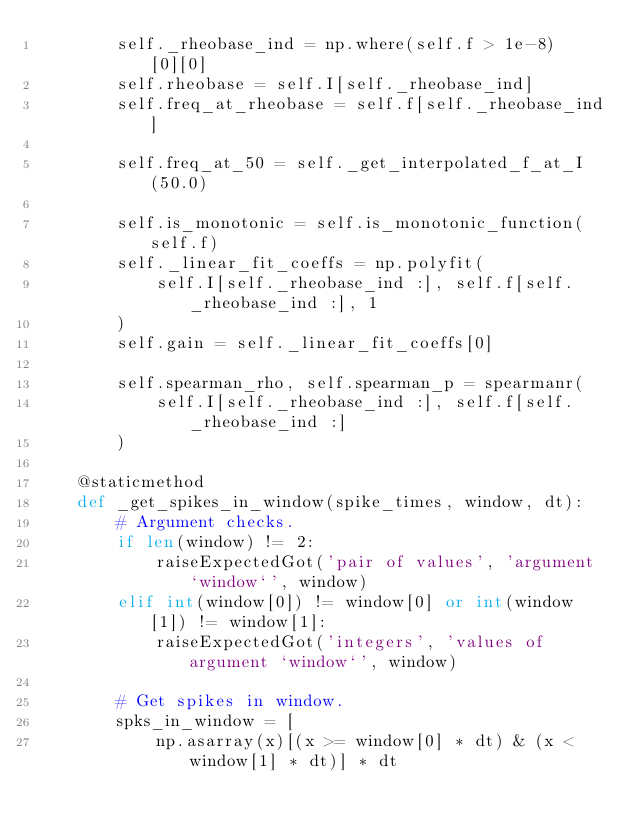<code> <loc_0><loc_0><loc_500><loc_500><_Python_>        self._rheobase_ind = np.where(self.f > 1e-8)[0][0]
        self.rheobase = self.I[self._rheobase_ind]
        self.freq_at_rheobase = self.f[self._rheobase_ind]

        self.freq_at_50 = self._get_interpolated_f_at_I(50.0)

        self.is_monotonic = self.is_monotonic_function(self.f)
        self._linear_fit_coeffs = np.polyfit(
            self.I[self._rheobase_ind :], self.f[self._rheobase_ind :], 1
        )
        self.gain = self._linear_fit_coeffs[0]

        self.spearman_rho, self.spearman_p = spearmanr(
            self.I[self._rheobase_ind :], self.f[self._rheobase_ind :]
        )

    @staticmethod
    def _get_spikes_in_window(spike_times, window, dt):
        # Argument checks.
        if len(window) != 2:
            raiseExpectedGot('pair of values', 'argument `window`', window)
        elif int(window[0]) != window[0] or int(window[1]) != window[1]:
            raiseExpectedGot('integers', 'values of argument `window`', window)

        # Get spikes in window.
        spks_in_window = [
            np.asarray(x)[(x >= window[0] * dt) & (x < window[1] * dt)] * dt</code> 